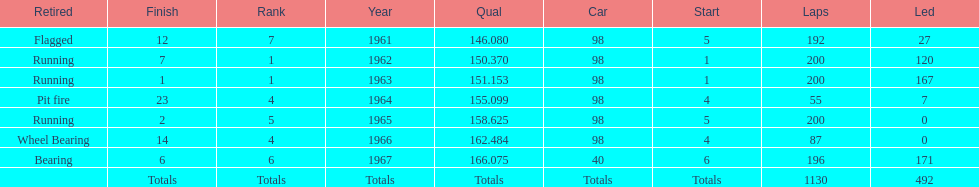What was his best finish before his first win? 7. 